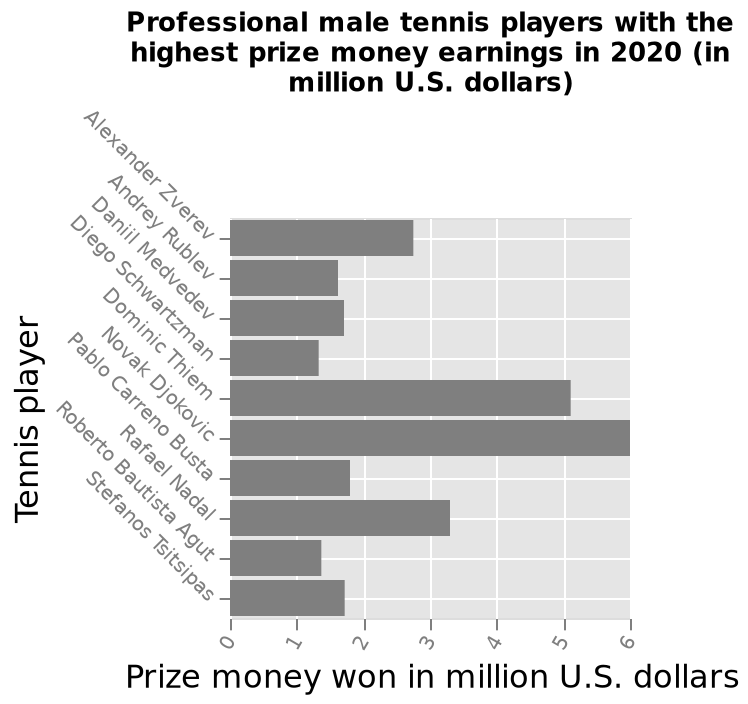<image>
What year does the bar plot data represent? The bar plot data represents the highest prize money earnings for professional male tennis players in 2020. Who had the highest prize money earnings in 2020?  Novak Djokovic What does the x-axis represent in the bar plot? The x-axis represents the prize money won in million U.S. dollars, with a range from 0 to 6. How many categories are represented on the y-axis of the bar plot? There are multiple categories represented on the y-axis, each corresponding to a different professional male tennis player. What does the y-axis represent in the bar plot? The y-axis represents the tennis players, with Alexander Zverev as the starting point and Stefanos Tsitsipas as the ending point. How much higher than the average prize money earnings was Novak Djokovic's earnings in 2020?  $3.45m 